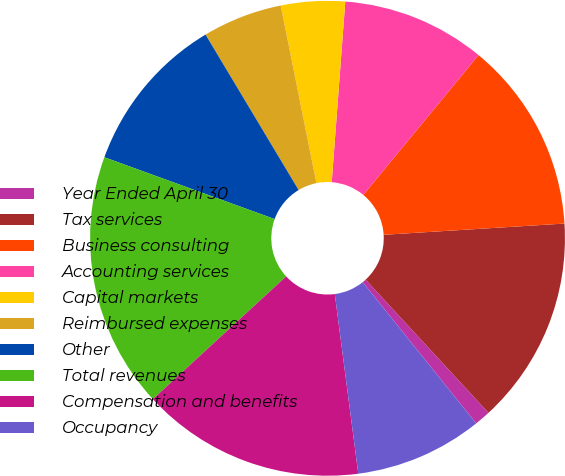Convert chart to OTSL. <chart><loc_0><loc_0><loc_500><loc_500><pie_chart><fcel>Year Ended April 30<fcel>Tax services<fcel>Business consulting<fcel>Accounting services<fcel>Capital markets<fcel>Reimbursed expenses<fcel>Other<fcel>Total revenues<fcel>Compensation and benefits<fcel>Occupancy<nl><fcel>1.09%<fcel>14.13%<fcel>13.04%<fcel>9.78%<fcel>4.35%<fcel>5.43%<fcel>10.87%<fcel>17.39%<fcel>15.22%<fcel>8.7%<nl></chart> 